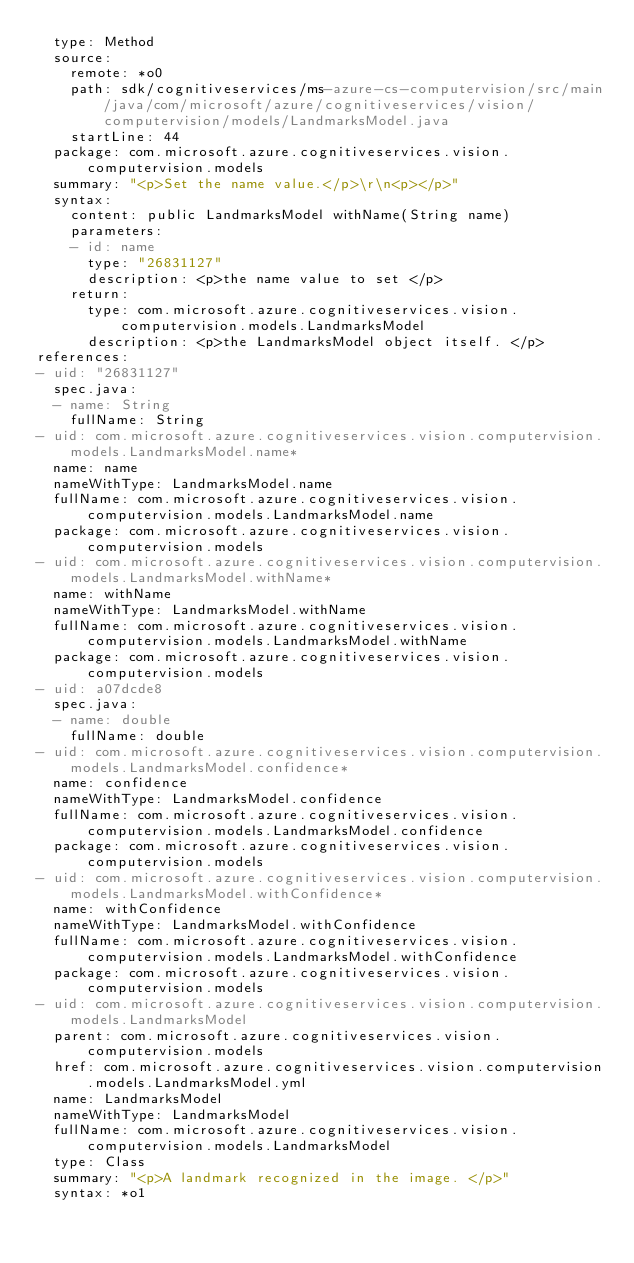Convert code to text. <code><loc_0><loc_0><loc_500><loc_500><_YAML_>  type: Method
  source:
    remote: *o0
    path: sdk/cognitiveservices/ms-azure-cs-computervision/src/main/java/com/microsoft/azure/cognitiveservices/vision/computervision/models/LandmarksModel.java
    startLine: 44
  package: com.microsoft.azure.cognitiveservices.vision.computervision.models
  summary: "<p>Set the name value.</p>\r\n<p></p>"
  syntax:
    content: public LandmarksModel withName(String name)
    parameters:
    - id: name
      type: "26831127"
      description: <p>the name value to set </p>
    return:
      type: com.microsoft.azure.cognitiveservices.vision.computervision.models.LandmarksModel
      description: <p>the LandmarksModel object itself. </p>
references:
- uid: "26831127"
  spec.java:
  - name: String
    fullName: String
- uid: com.microsoft.azure.cognitiveservices.vision.computervision.models.LandmarksModel.name*
  name: name
  nameWithType: LandmarksModel.name
  fullName: com.microsoft.azure.cognitiveservices.vision.computervision.models.LandmarksModel.name
  package: com.microsoft.azure.cognitiveservices.vision.computervision.models
- uid: com.microsoft.azure.cognitiveservices.vision.computervision.models.LandmarksModel.withName*
  name: withName
  nameWithType: LandmarksModel.withName
  fullName: com.microsoft.azure.cognitiveservices.vision.computervision.models.LandmarksModel.withName
  package: com.microsoft.azure.cognitiveservices.vision.computervision.models
- uid: a07dcde8
  spec.java:
  - name: double
    fullName: double
- uid: com.microsoft.azure.cognitiveservices.vision.computervision.models.LandmarksModel.confidence*
  name: confidence
  nameWithType: LandmarksModel.confidence
  fullName: com.microsoft.azure.cognitiveservices.vision.computervision.models.LandmarksModel.confidence
  package: com.microsoft.azure.cognitiveservices.vision.computervision.models
- uid: com.microsoft.azure.cognitiveservices.vision.computervision.models.LandmarksModel.withConfidence*
  name: withConfidence
  nameWithType: LandmarksModel.withConfidence
  fullName: com.microsoft.azure.cognitiveservices.vision.computervision.models.LandmarksModel.withConfidence
  package: com.microsoft.azure.cognitiveservices.vision.computervision.models
- uid: com.microsoft.azure.cognitiveservices.vision.computervision.models.LandmarksModel
  parent: com.microsoft.azure.cognitiveservices.vision.computervision.models
  href: com.microsoft.azure.cognitiveservices.vision.computervision.models.LandmarksModel.yml
  name: LandmarksModel
  nameWithType: LandmarksModel
  fullName: com.microsoft.azure.cognitiveservices.vision.computervision.models.LandmarksModel
  type: Class
  summary: "<p>A landmark recognized in the image. </p>"
  syntax: *o1
</code> 